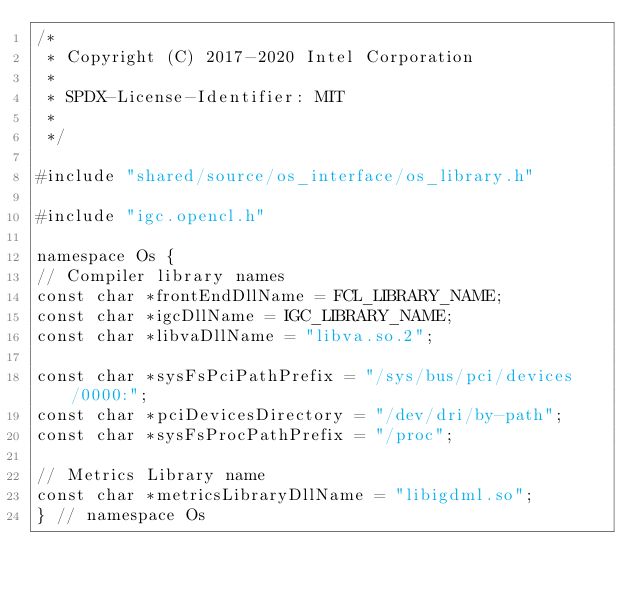<code> <loc_0><loc_0><loc_500><loc_500><_C++_>/*
 * Copyright (C) 2017-2020 Intel Corporation
 *
 * SPDX-License-Identifier: MIT
 *
 */

#include "shared/source/os_interface/os_library.h"

#include "igc.opencl.h"

namespace Os {
// Compiler library names
const char *frontEndDllName = FCL_LIBRARY_NAME;
const char *igcDllName = IGC_LIBRARY_NAME;
const char *libvaDllName = "libva.so.2";

const char *sysFsPciPathPrefix = "/sys/bus/pci/devices/0000:";
const char *pciDevicesDirectory = "/dev/dri/by-path";
const char *sysFsProcPathPrefix = "/proc";

// Metrics Library name
const char *metricsLibraryDllName = "libigdml.so";
} // namespace Os
</code> 